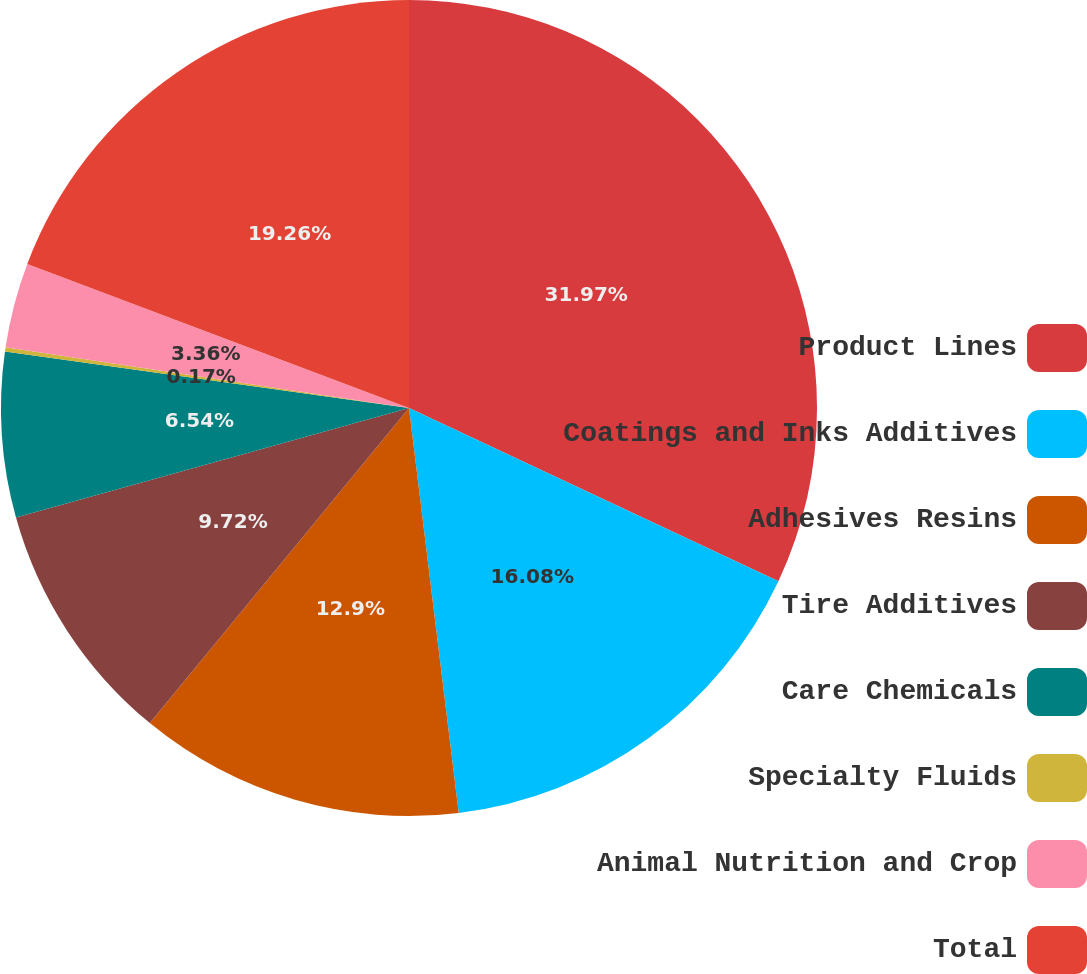Convert chart to OTSL. <chart><loc_0><loc_0><loc_500><loc_500><pie_chart><fcel>Product Lines<fcel>Coatings and Inks Additives<fcel>Adhesives Resins<fcel>Tire Additives<fcel>Care Chemicals<fcel>Specialty Fluids<fcel>Animal Nutrition and Crop<fcel>Total<nl><fcel>31.98%<fcel>16.08%<fcel>12.9%<fcel>9.72%<fcel>6.54%<fcel>0.17%<fcel>3.36%<fcel>19.26%<nl></chart> 